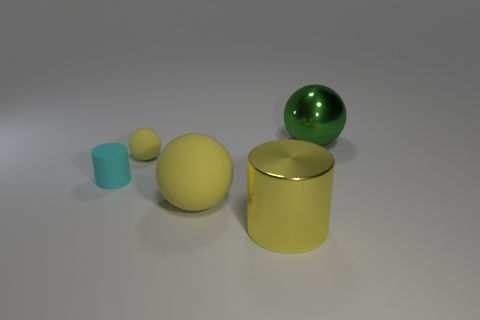What is the color distribution of the objects in the image? In the image, there are several objects with distinct colors. There is one cyan cylinder, a large green sphere, one large yellow ball, and a big yellow cylinder that seems metallic. Additionally, there appears to be a small yellow object as well. 